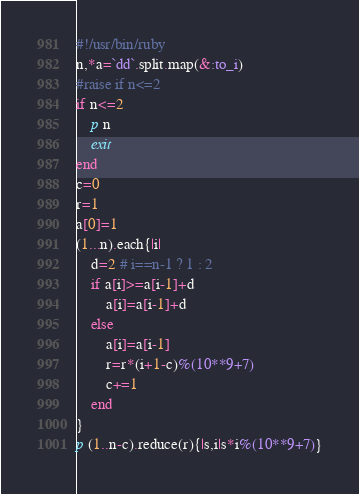<code> <loc_0><loc_0><loc_500><loc_500><_Ruby_>#!/usr/bin/ruby
n,*a=`dd`.split.map(&:to_i)
#raise if n<=2
if n<=2
	p n
	exit
end
c=0
r=1
a[0]=1
(1...n).each{|i|
	d=2 # i==n-1 ? 1 : 2
	if a[i]>=a[i-1]+d
		a[i]=a[i-1]+d
	else
		a[i]=a[i-1]
		r=r*(i+1-c)%(10**9+7)
		c+=1
	end
}
p (1..n-c).reduce(r){|s,i|s*i%(10**9+7)}</code> 